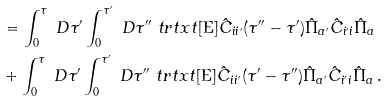Convert formula to latex. <formula><loc_0><loc_0><loc_500><loc_500>& = \int _ { 0 } ^ { \tau } \ D \tau ^ { \prime } \int _ { 0 } ^ { \tau ^ { \prime } } \ D \tau ^ { \prime \prime } \ t r t x t [ \text {E} ] { \hat { C } _ { i i ^ { \prime } } ( \tau ^ { \prime \prime } - \tau ^ { \prime } ) \hat { \Pi } _ { a ^ { \prime } } \hat { C } _ { i ^ { \prime } i } \hat { \Pi } _ { a } } \\ & + \int _ { 0 } ^ { \tau } \ D \tau ^ { \prime } \int _ { 0 } ^ { \tau ^ { \prime } } \ D \tau ^ { \prime \prime } \ t r t x t [ \text {E} ] { \hat { C } _ { i i ^ { \prime } } ( \tau ^ { \prime } - \tau ^ { \prime \prime } ) \hat { \Pi } _ { a ^ { \prime } } \hat { C } _ { i ^ { \prime } i } \hat { \Pi } _ { a } } \, .</formula> 